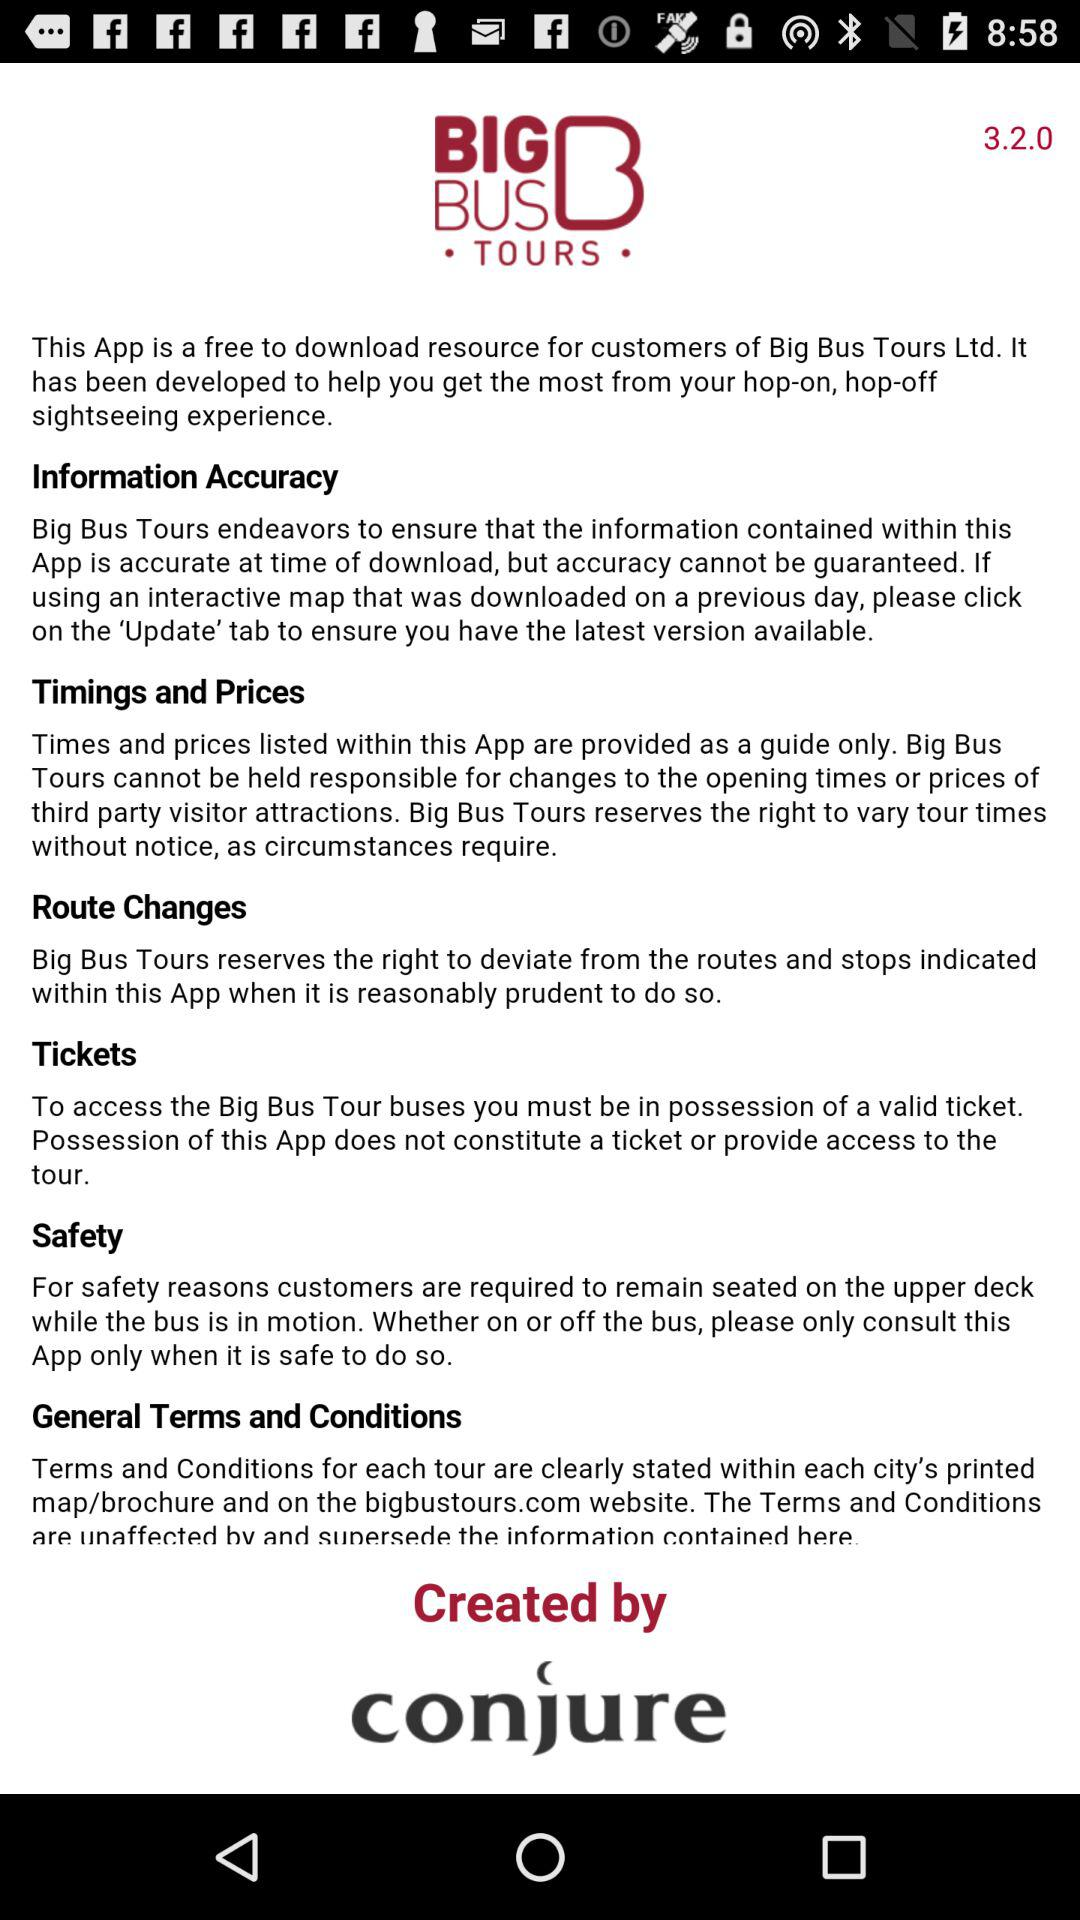What are the general terms and conditions in big bus tours?
When the provided information is insufficient, respond with <no answer>. <no answer> 